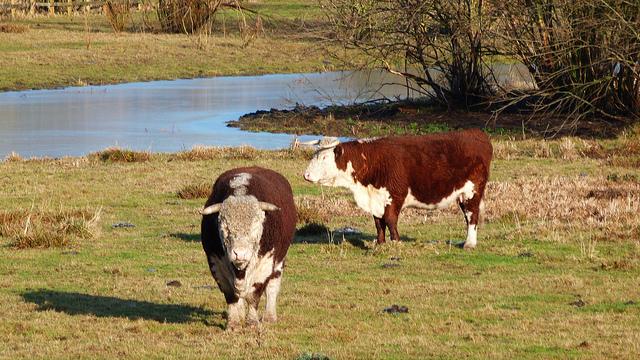How many cattle are in the scene?
Write a very short answer. 2. Where are the cows at?
Give a very brief answer. Field. Are the cattle in their natural habitat?
Write a very short answer. Yes. How many animals are depicted?
Short answer required. 2. 